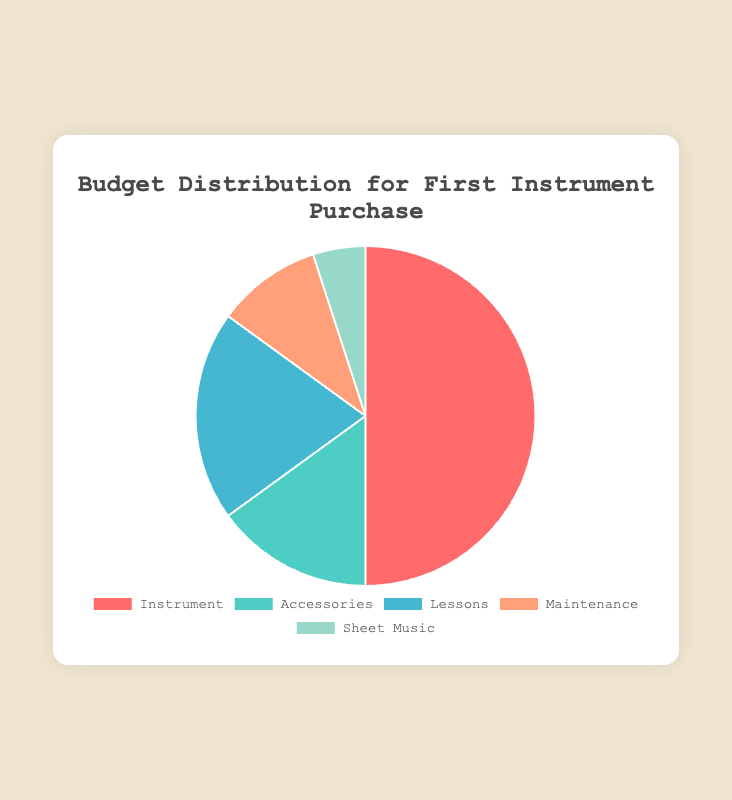What percentage of the budget is allocated to Lessons? The slice labeled "Lessons" shows a percentage value. It states that "Lessons" take up 20% of the total budget.
Answer: 20% Which category occupies the largest portion of the budget? By observing the pie chart, the largest slice is labeled "Instrument," indicating it has the highest percentage.
Answer: Instrument What is the combined budget percentage for Accessories and Maintenance? Add the percentages allocated to "Accessories" and "Maintenance": 15% + 10% = 25%.
Answer: 25% How much more budget is allocated to Instrument compared to Sheet Music? Subtract the percentage allocated to Sheet Music from that for Instrument: 50% - 5% = 45%.
Answer: 45% Which category has the smallest budget allocation, and what color represents it? Identify the smallest slice in the pie chart, which is labeled "Sheet Music" and colored in light green.
Answer: Sheet Music, light green What is the budget difference between Accessories and Lessons? Subtract the percentage allocated to Accessories from that for Lessons: 20% - 15% = 5%.
Answer: 5% Name all the categories that have a smaller budget allocation than Lessons. The pie chart shows that "Accessories," "Maintenance," and "Sheet Music" each have a smaller allocation than Lessons, which is 20%.
Answer: Accessories, Maintenance, Sheet Music 